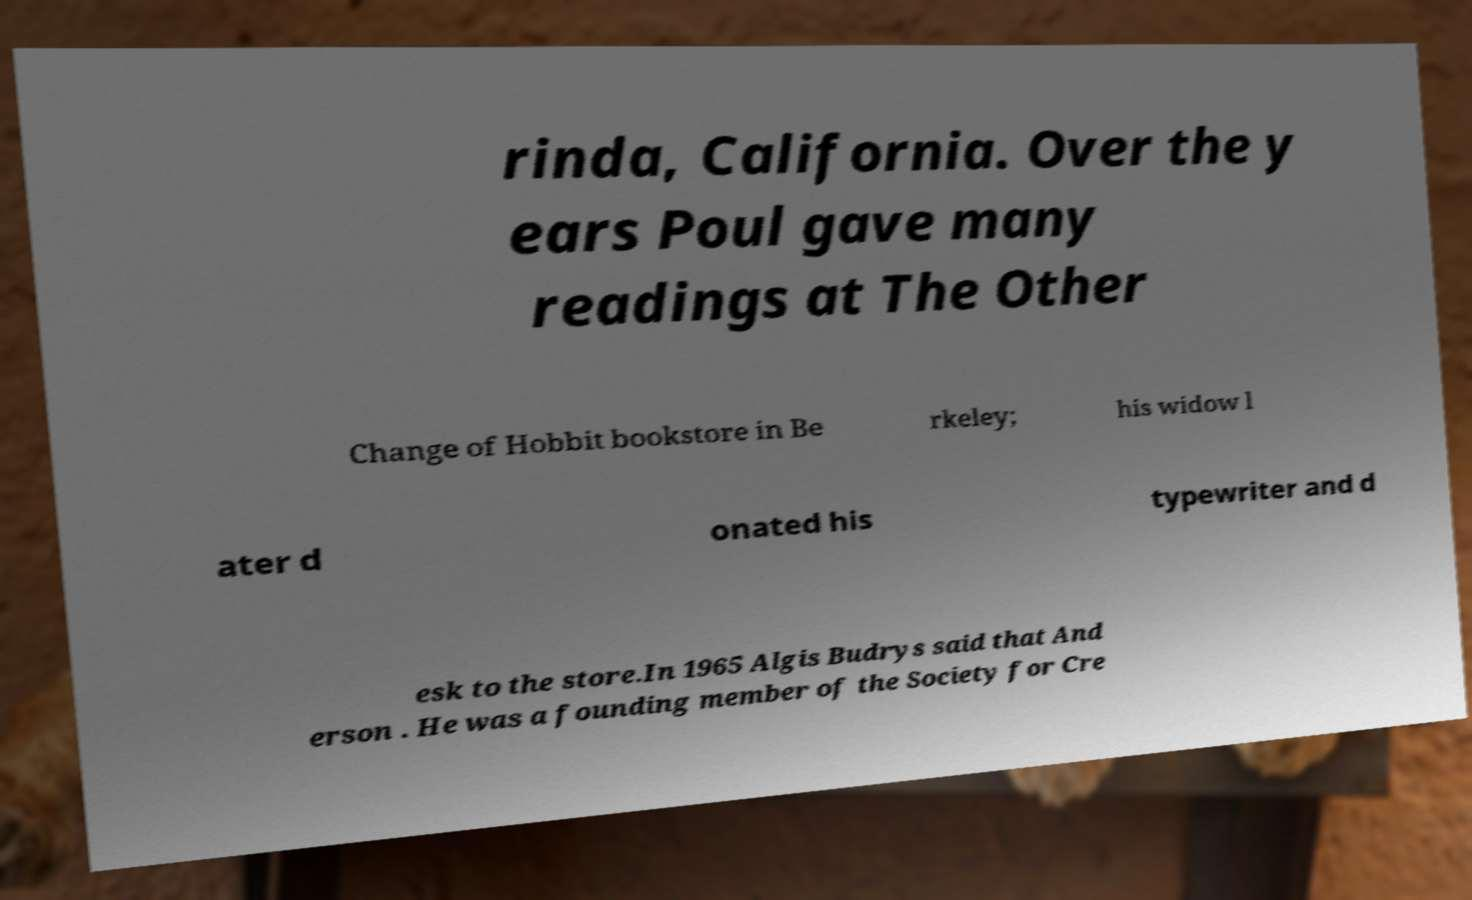Please identify and transcribe the text found in this image. rinda, California. Over the y ears Poul gave many readings at The Other Change of Hobbit bookstore in Be rkeley; his widow l ater d onated his typewriter and d esk to the store.In 1965 Algis Budrys said that And erson . He was a founding member of the Society for Cre 